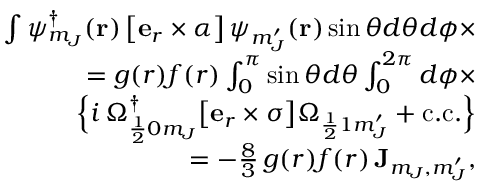Convert formula to latex. <formula><loc_0><loc_0><loc_500><loc_500>\begin{array} { r l r } & { \int \psi _ { m _ { J } } ^ { \dag } ( r ) \, \left [ e _ { r } \times \boldsymbol \alpha \right ] \, \psi _ { m _ { J } ^ { \prime } } ( r ) \sin \theta d \theta d \phi \times } \\ & { = g ( r ) f ( r ) \int _ { 0 } ^ { \pi } \sin \theta d \theta \int _ { 0 } ^ { 2 \pi } d \phi \times } \\ & { \left \{ i \, \Omega _ { \frac { 1 } { 2 } 0 m _ { J } } ^ { \dag } \left [ e _ { r } \times \boldsymbol \sigma \right ] \Omega _ { \frac { 1 } { 2 } 1 m _ { J } ^ { \prime } } + c . c . \right \} } \\ & { = - \frac { 8 } { 3 } \, g ( r ) f ( r ) \, J _ { m _ { J } , m _ { J } ^ { \prime } } , } \end{array}</formula> 